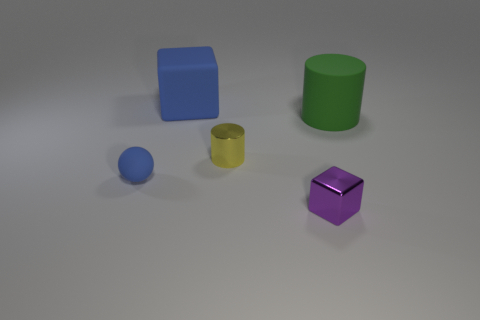How many things are both behind the ball and left of the green cylinder?
Provide a succinct answer. 2. Is there any other thing that has the same size as the green rubber cylinder?
Offer a terse response. Yes. Is the number of small balls in front of the big blue rubber cube greater than the number of large green cylinders in front of the shiny cylinder?
Offer a very short reply. Yes. There is a big thing that is on the right side of the shiny cube; what is it made of?
Keep it short and to the point. Rubber. Is the shape of the yellow shiny thing the same as the big thing on the left side of the matte cylinder?
Your response must be concise. No. How many matte things are left of the rubber object that is in front of the large matte object on the right side of the purple object?
Offer a terse response. 0. There is a small metal object that is the same shape as the big blue matte thing; what color is it?
Offer a very short reply. Purple. Is there any other thing that has the same shape as the tiny blue matte object?
Your answer should be very brief. No. What number of cylinders are either rubber objects or tiny yellow metallic objects?
Make the answer very short. 2. What is the shape of the tiny yellow object?
Keep it short and to the point. Cylinder. 